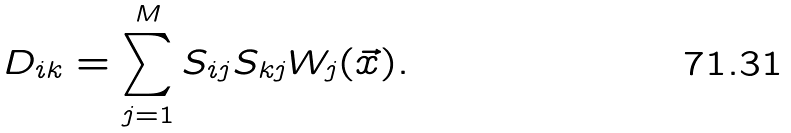<formula> <loc_0><loc_0><loc_500><loc_500>D _ { i k } = \sum _ { j = 1 } ^ { M } S _ { i j } S _ { k j } W _ { j } ( \vec { x } ) .</formula> 